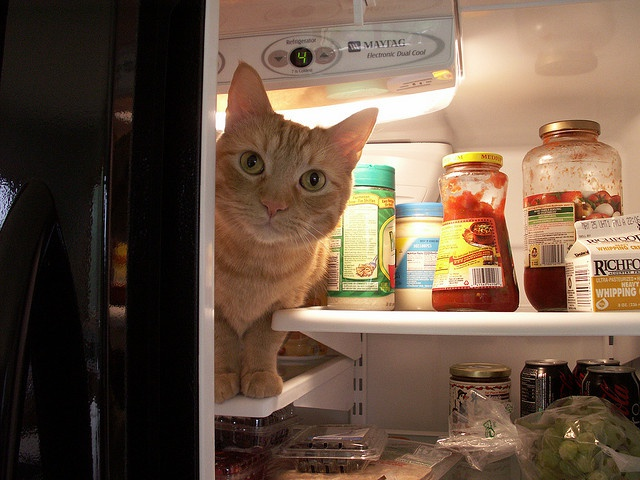Describe the objects in this image and their specific colors. I can see refrigerator in black, gray, and maroon tones, refrigerator in black, gray, maroon, and darkgray tones, cat in black, maroon, and brown tones, bottle in black, tan, and maroon tones, and bottle in black, maroon, khaki, brown, and red tones in this image. 